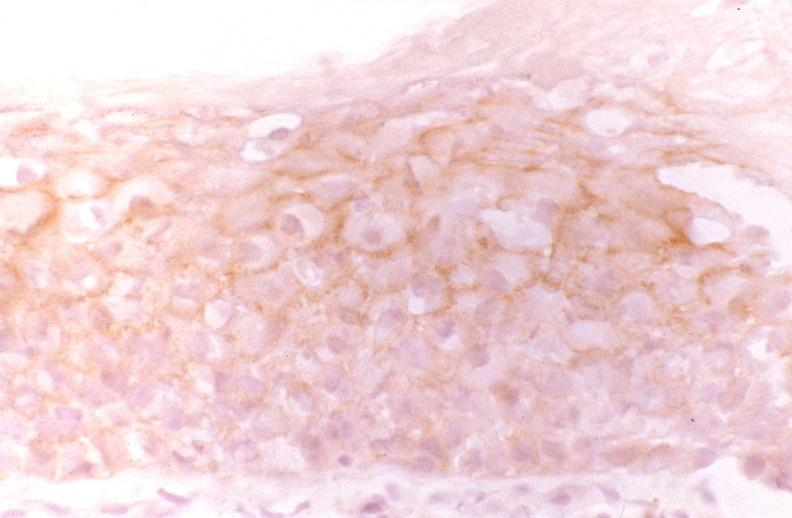where is this from?
Answer the question using a single word or phrase. Gastrointestinal system 